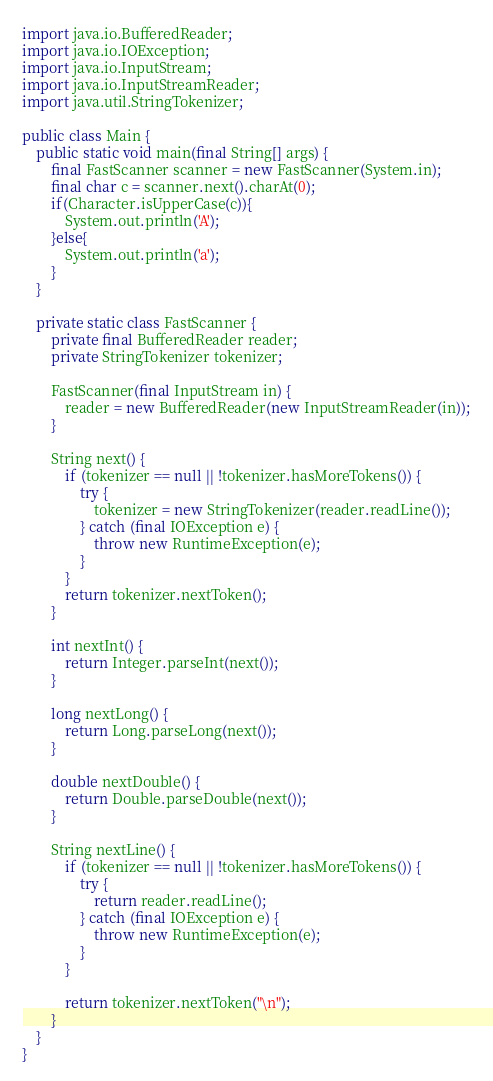Convert code to text. <code><loc_0><loc_0><loc_500><loc_500><_Java_>
import java.io.BufferedReader;
import java.io.IOException;
import java.io.InputStream;
import java.io.InputStreamReader;
import java.util.StringTokenizer;

public class Main {
    public static void main(final String[] args) {
        final FastScanner scanner = new FastScanner(System.in);
        final char c = scanner.next().charAt(0);
        if(Character.isUpperCase(c)){
            System.out.println('A');
        }else{
            System.out.println('a');
        }
    }

    private static class FastScanner {
        private final BufferedReader reader;
        private StringTokenizer tokenizer;

        FastScanner(final InputStream in) {
            reader = new BufferedReader(new InputStreamReader(in));
        }

        String next() {
            if (tokenizer == null || !tokenizer.hasMoreTokens()) {
                try {
                    tokenizer = new StringTokenizer(reader.readLine());
                } catch (final IOException e) {
                    throw new RuntimeException(e);
                }
            }
            return tokenizer.nextToken();
        }

        int nextInt() {
            return Integer.parseInt(next());
        }

        long nextLong() {
            return Long.parseLong(next());
        }

        double nextDouble() {
            return Double.parseDouble(next());
        }

        String nextLine() {
            if (tokenizer == null || !tokenizer.hasMoreTokens()) {
                try {
                    return reader.readLine();
                } catch (final IOException e) {
                    throw new RuntimeException(e);
                }
            }

            return tokenizer.nextToken("\n");
        }
    }
}
</code> 